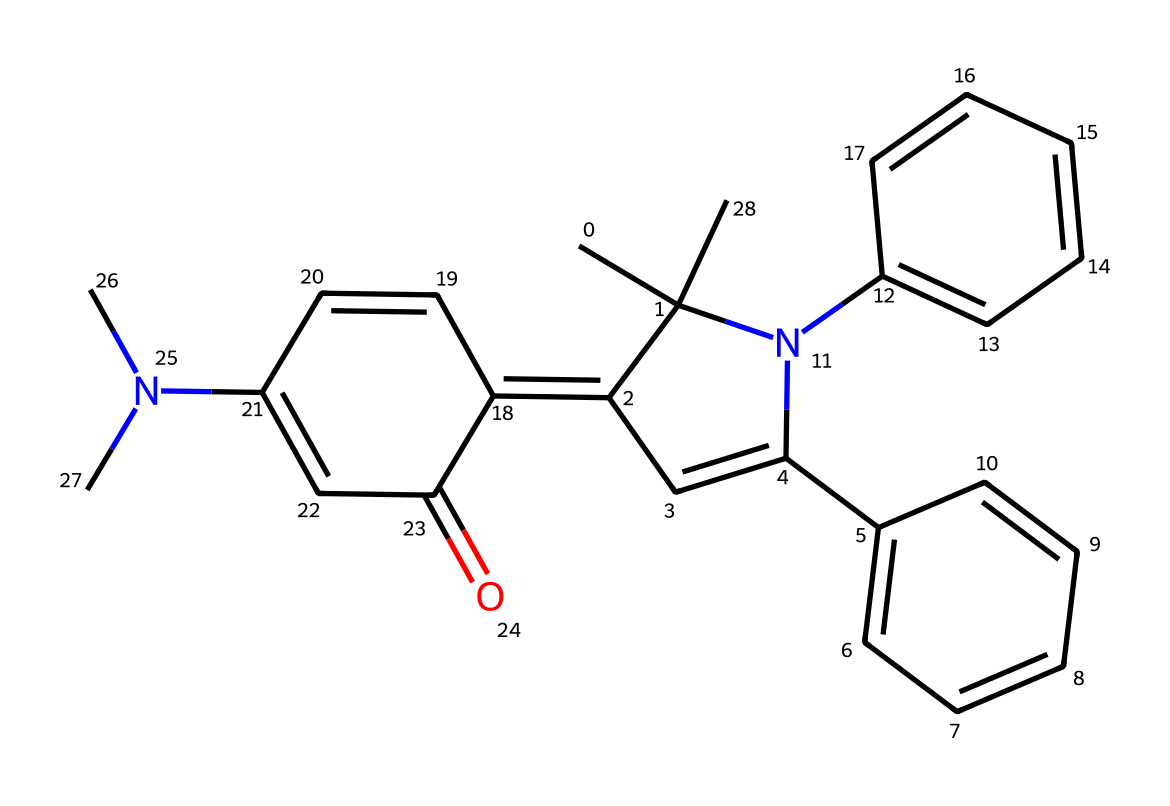What is the molecular formula of spiropyran? By interpreting the provided SMILES representation, we can identify the atoms present in the structure. The SMILES indicates a composition of carbon (C), hydrogen (H), nitrogen (N), and oxygen (O). Counting these gives the molecular formula C20H20N2O.
Answer: C20H20N2O How many rings are present in the structure of spiropyran? Observing the structure, there are multiple cyclic arrangements; specifically, I can count four identifiable rings present in the spiropyran structure.
Answer: 4 What type of chemical compound is spiropyran? Evaluating the molecular structure, spiropyran fits the category of a photochromic compound because it can undergo reversible transformation when exposed to light.
Answer: photochromic Which atoms are connected to nitrogen in this chemical? Analyzing the SMILES structure reveals that nitrogen atoms are connected to carbon chains and adjacent carbon rings, linking them to an overall complex arrangement. Specifically, one nitrogen is associated with three carbon atoms.
Answer: carbon How does light exposure affect spiropyran's structure? Understanding the behavior of spiropyran under different light conditions indicates that exposure to UV light leads to a structural isomerization that alters its color. This change is reversible when the light source is removed.
Answer: isomerization What are the uses of spiropyran in digital printing? Recognizing the properties of spiropyran, including its color change ability, I can conclude that it is widely used in light-sensitive inks where its photochromic properties allow for dynamic color performance in printing applications.
Answer: light-sensitive inks 